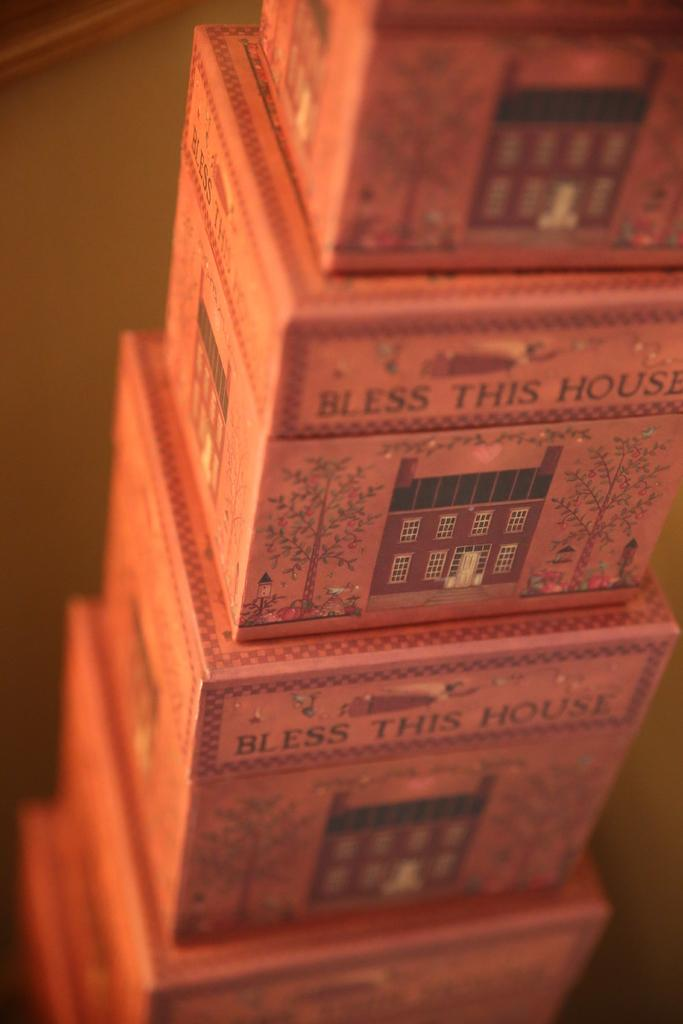<image>
Relay a brief, clear account of the picture shown. A stack of small square boxes with an inscription on them of "Bless This House" 